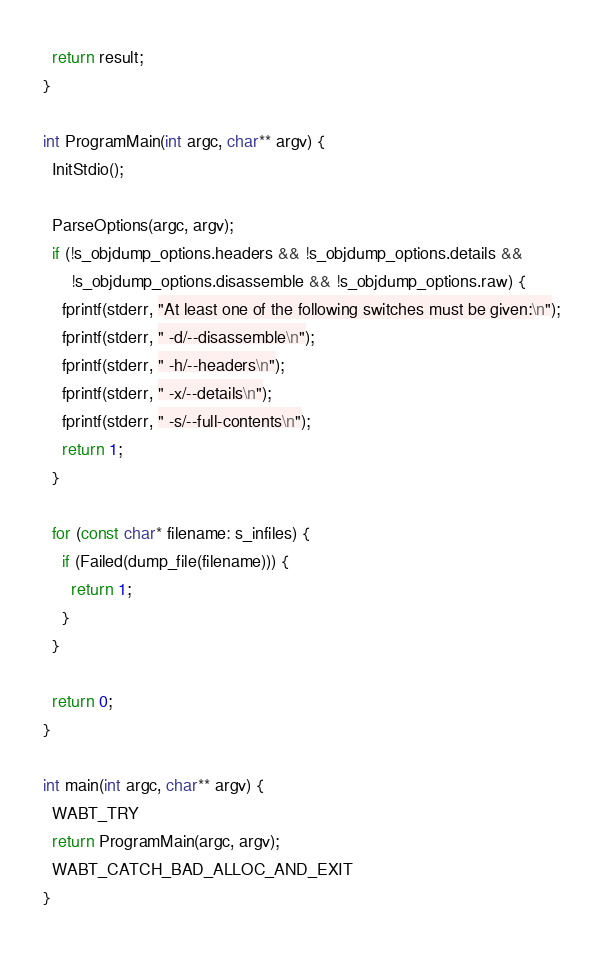Convert code to text. <code><loc_0><loc_0><loc_500><loc_500><_C++_>
  return result;
}

int ProgramMain(int argc, char** argv) {
  InitStdio();

  ParseOptions(argc, argv);
  if (!s_objdump_options.headers && !s_objdump_options.details &&
      !s_objdump_options.disassemble && !s_objdump_options.raw) {
    fprintf(stderr, "At least one of the following switches must be given:\n");
    fprintf(stderr, " -d/--disassemble\n");
    fprintf(stderr, " -h/--headers\n");
    fprintf(stderr, " -x/--details\n");
    fprintf(stderr, " -s/--full-contents\n");
    return 1;
  }

  for (const char* filename: s_infiles) {
    if (Failed(dump_file(filename))) {
      return 1;
    }
  }

  return 0;
}

int main(int argc, char** argv) {
  WABT_TRY
  return ProgramMain(argc, argv);
  WABT_CATCH_BAD_ALLOC_AND_EXIT
}
</code> 